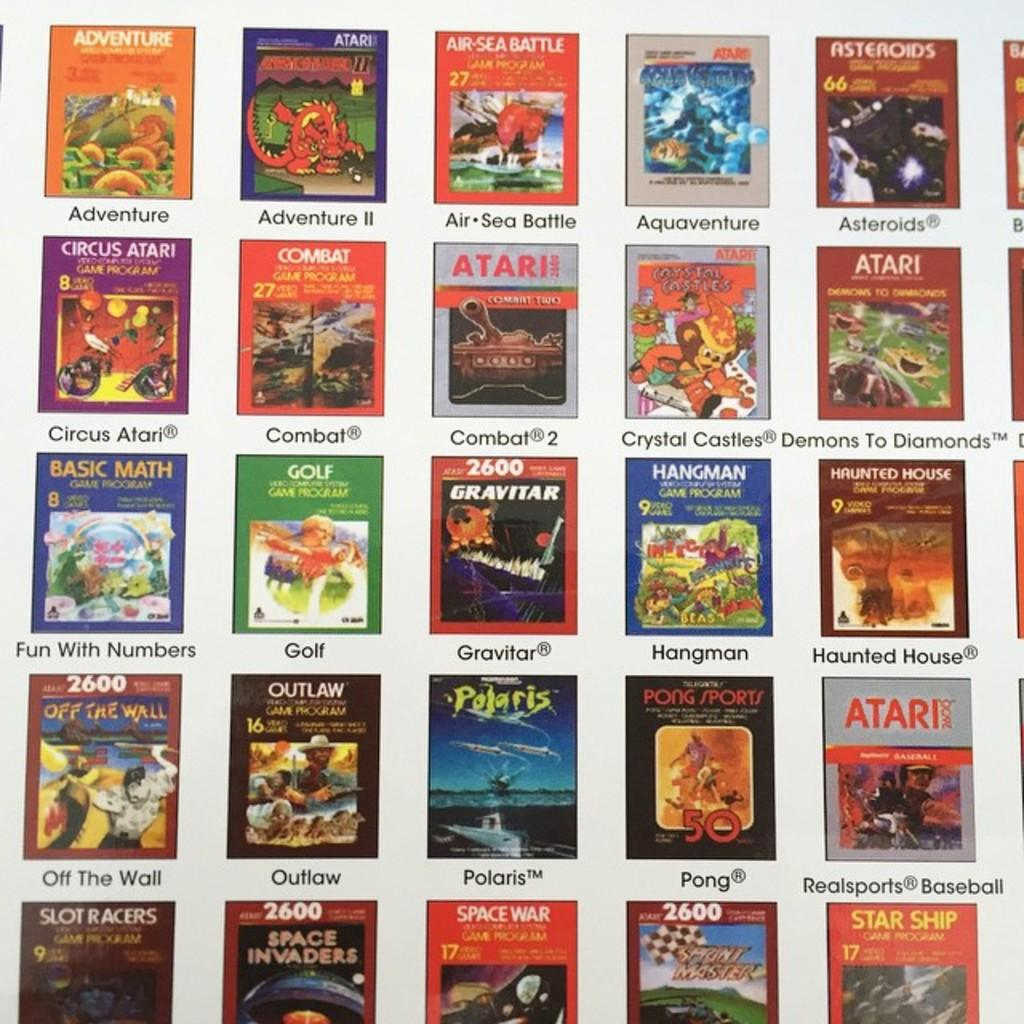Provide a one-sentence caption for the provided image. Collection of books of math, golf, atari, and space. 